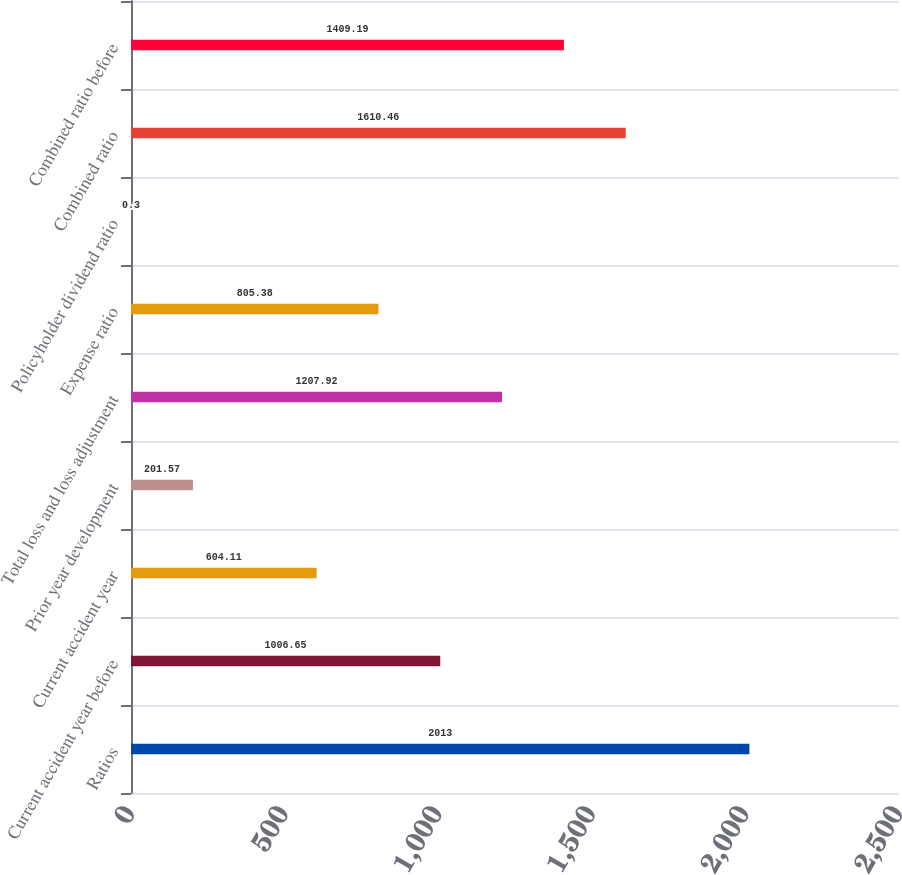Convert chart. <chart><loc_0><loc_0><loc_500><loc_500><bar_chart><fcel>Ratios<fcel>Current accident year before<fcel>Current accident year<fcel>Prior year development<fcel>Total loss and loss adjustment<fcel>Expense ratio<fcel>Policyholder dividend ratio<fcel>Combined ratio<fcel>Combined ratio before<nl><fcel>2013<fcel>1006.65<fcel>604.11<fcel>201.57<fcel>1207.92<fcel>805.38<fcel>0.3<fcel>1610.46<fcel>1409.19<nl></chart> 